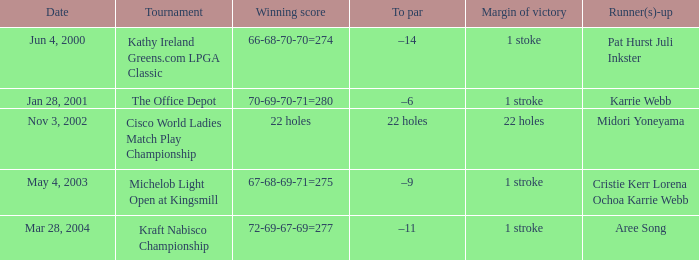What is the to par dated may 4, 2003? –9. 